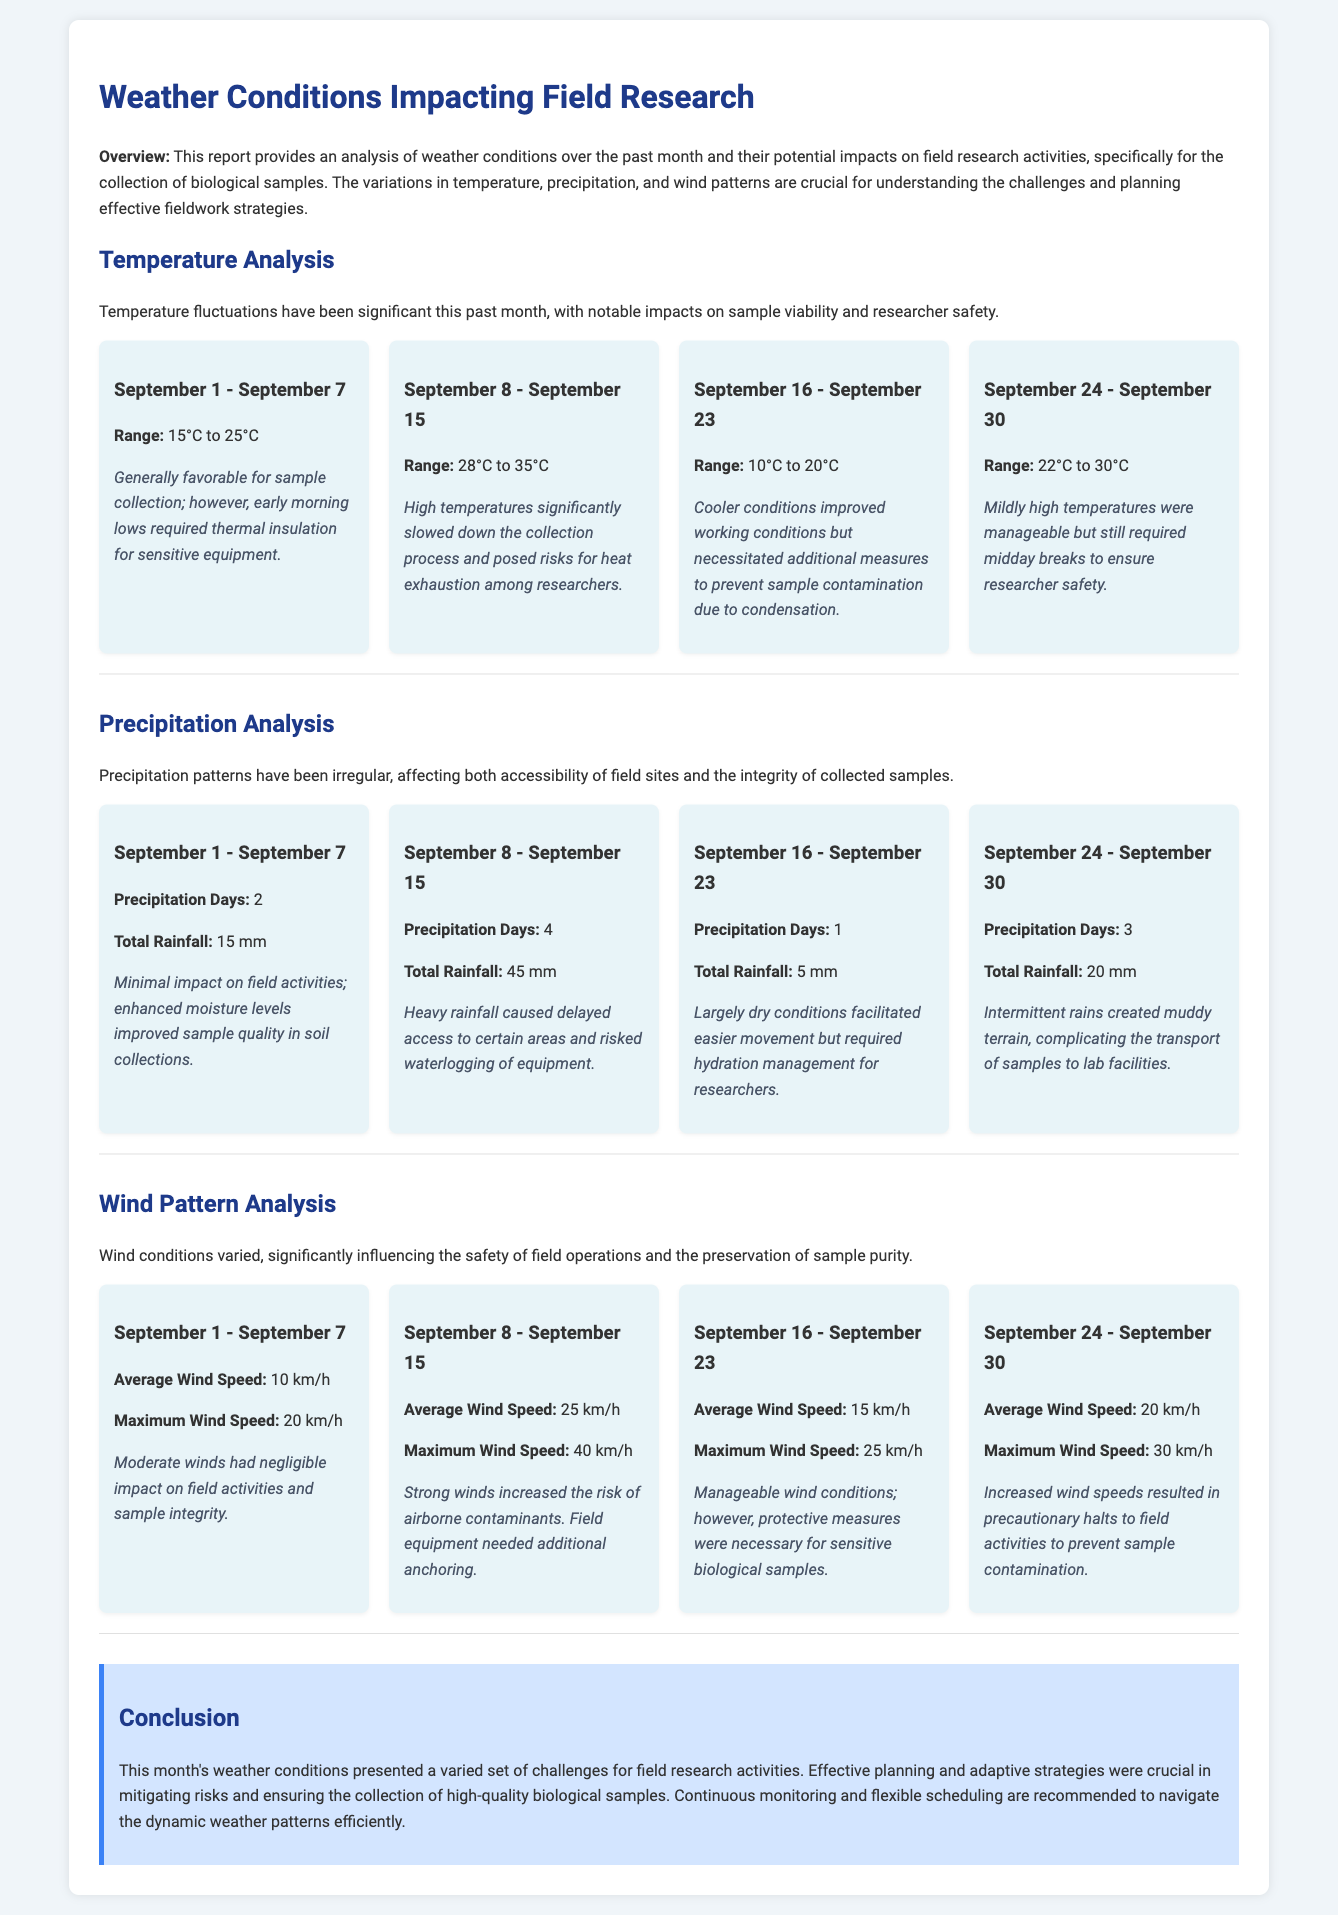What was the range of temperatures from September 8 to September 15? The range of temperatures during this period is specified in the temperature analysis section.
Answer: 28°C to 35°C How many days did it rain from September 16 to September 23? This information is detailed in the precipitation analysis section under that specific date range.
Answer: 1 What was the total rainfall from September 1 to September 7? The document specifies the total rainfall for those days in the precipitation analysis section.
Answer: 15 mm During which week was heat exhaustion a risk for researchers? The reasoning comes from examining temperature fluctuations that led to this risk.
Answer: September 8 to September 15 What was the maximum wind speed observed during September 24 to September 30? The maximum wind speed is found in the wind pattern analysis section for that date range.
Answer: 30 km/h What impact did minimal rainfall have on field activities during the first week? The document describes how minimal rainfall affected the conditions for sample collection.
Answer: Improved sample quality in soil collections Which week required additional measures to prevent sample contamination due to condensation? This is stated in the temperature analysis section for specific date ranges.
Answer: September 16 to September 23 How was sample integrity affected due to strong winds? The impact of strong winds on sample integrity is explained under the wind pattern analysis.
Answer: Airborne contaminants What type of report is this? The introduction clearly identifies the nature of the document.
Answer: Weather report 